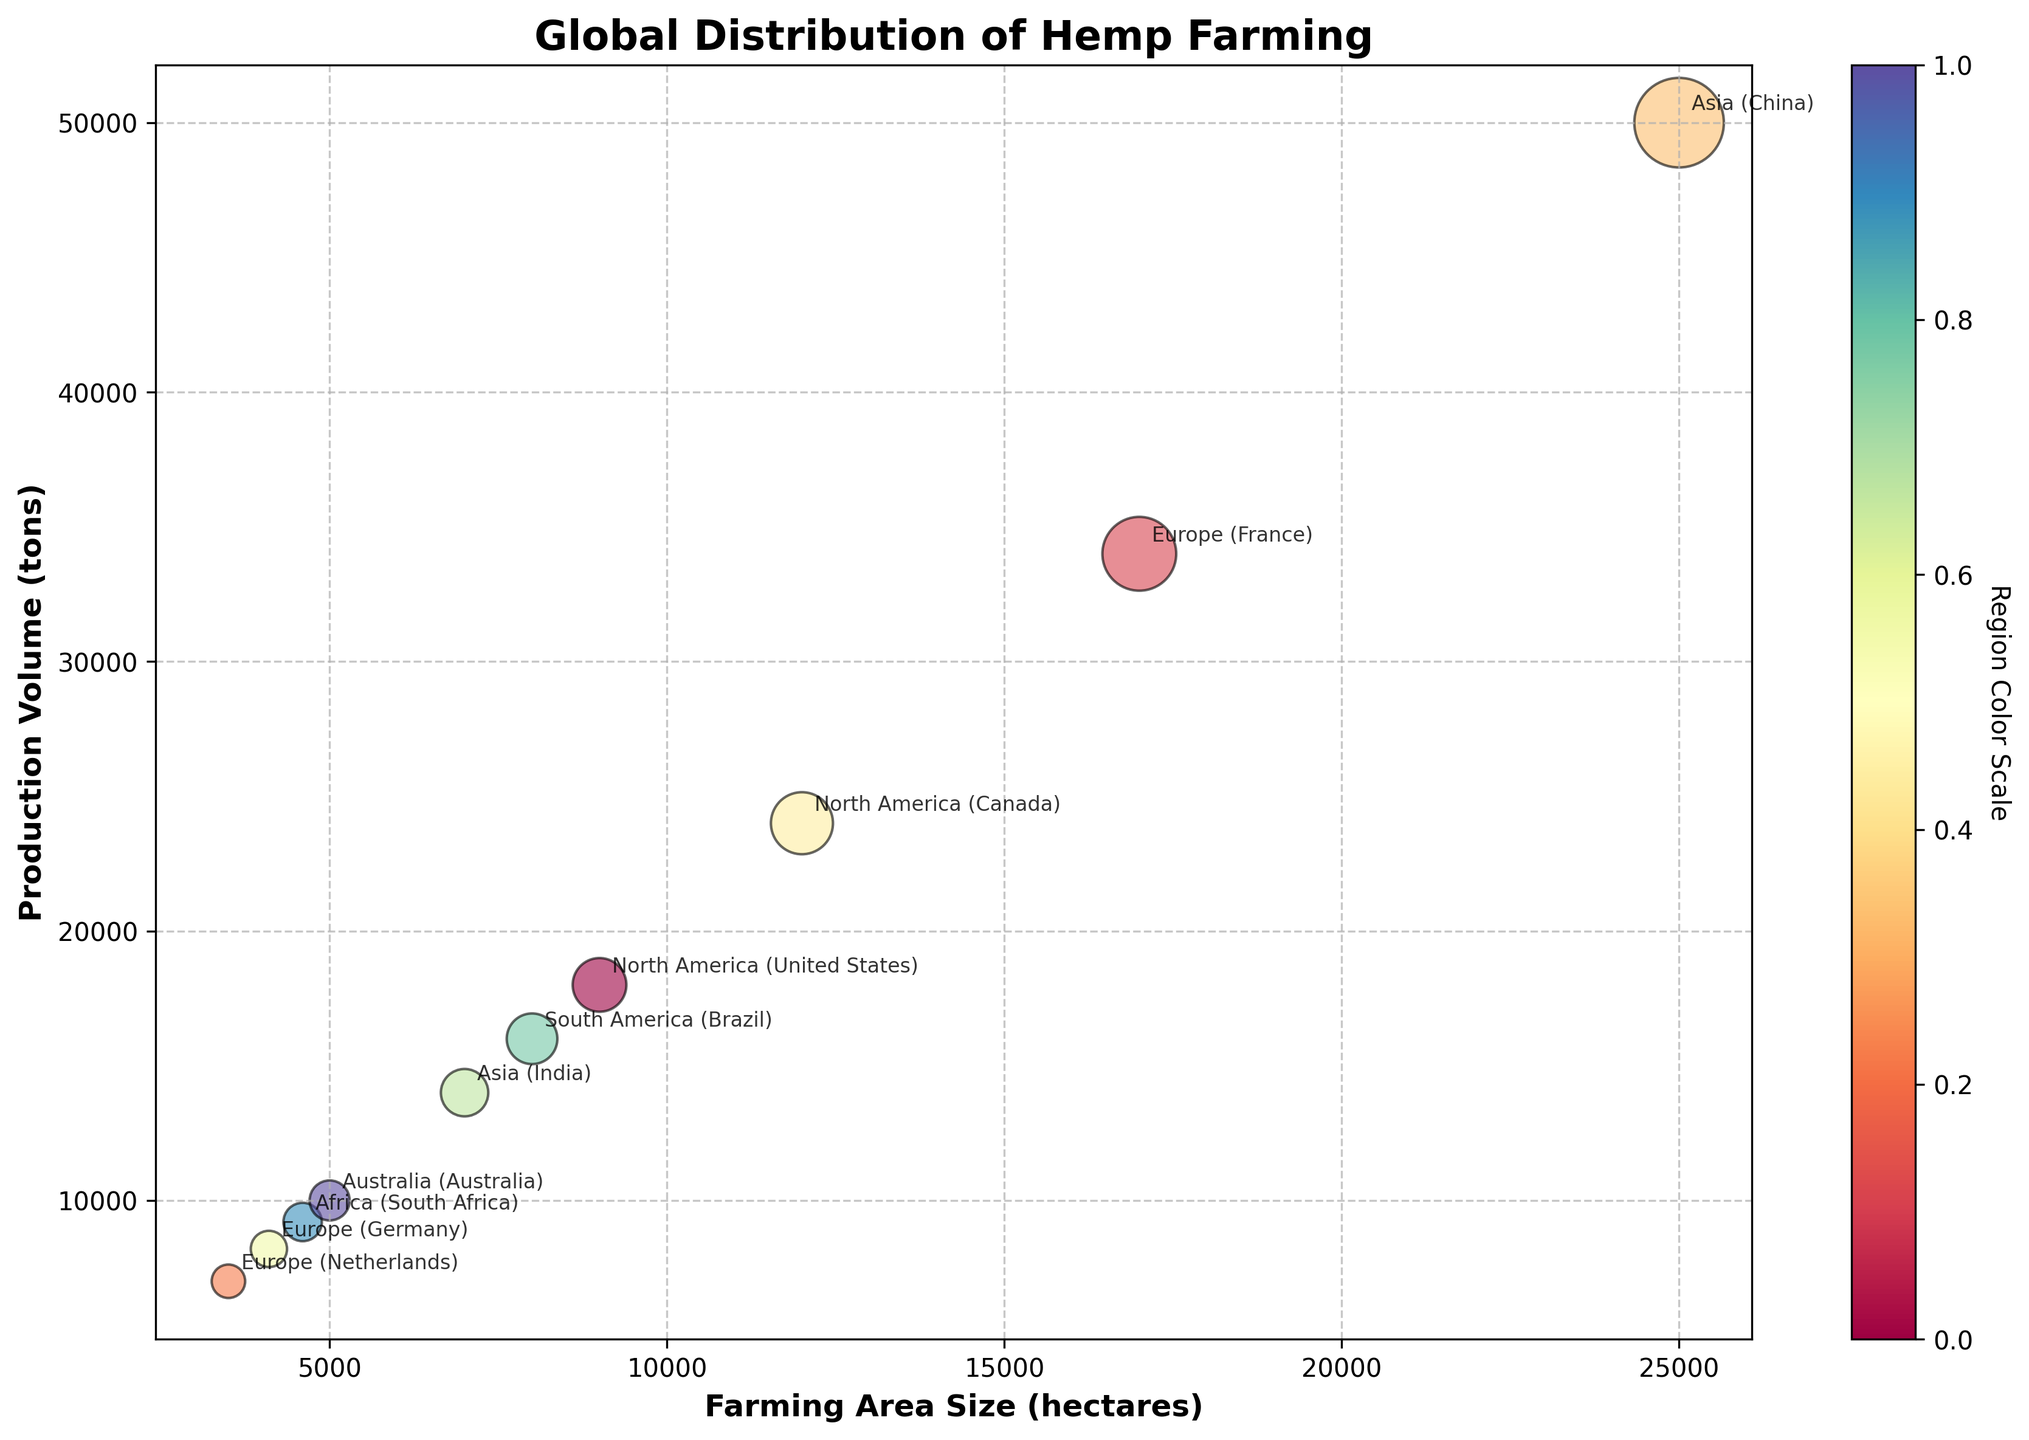How many regions are represented in the chart? Count the unique labels in the bubble chart, each representing a different region.
Answer: 10 Which region has the largest production volume? Look for the bubble with the highest value on the y-axis. China has the highest production volume at 50,000 tons.
Answer: China What is the total production volume for all regions combined? Sum the production volumes of all regions: 18,000 + 34,000 + 7,000 + 50,000 + 24,000 + 8,200 + 14,000 + 16,000 + 9,200 + 10,000. The total is 190,400 tons.
Answer: 190,400 tons How does the farming area of Canada compare to that of the United States? Compare the x-axis values for Canada (12,000 hectares) and the United States (9,000 hectares). Canada has a larger farming area size.
Answer: Canada has a larger farming area Which region has the smallest bubble in terms of farming area size? Look for the smallest bubble on the x-axis. The Netherlands, with 3,500 hectares, has the smallest farming area size.
Answer: Netherlands Is there any region with a higher production volume than farming area size? Compare the y-axis values (production volume) to the x-axis values (farming area size) for each region. None of the regions have a production volume higher than their farming area size.
Answer: None What is the average farming area size for the regions in Europe? Calculate the mean farming area size: (France 17,000 + Netherlands 3,500 + Germany 4,100) / 3. The average is (17,000 + 3,500 + 4,100) / 3 = 8,866.67 hectares.
Answer: 8,866.67 hectares Which region has the highest farming area size in Asia? Compare the x-axis values for the regions in Asia (China and India). China has the highest farming area size at 25,000 hectares.
Answer: China Do any bubbles overlap on the plot? Visually check if any bubbles appear to intersect or overlay each other. Due to the transparency, it's easy to notice that none of the bubbles overlap significantly.
Answer: No How does the production volume of Brazil compare to that of South Africa? Compare the y-axis values for Brazil (16,000 tons) and South Africa (9,200 tons). Brazil has a higher production volume.
Answer: Brazil has a higher production volume 